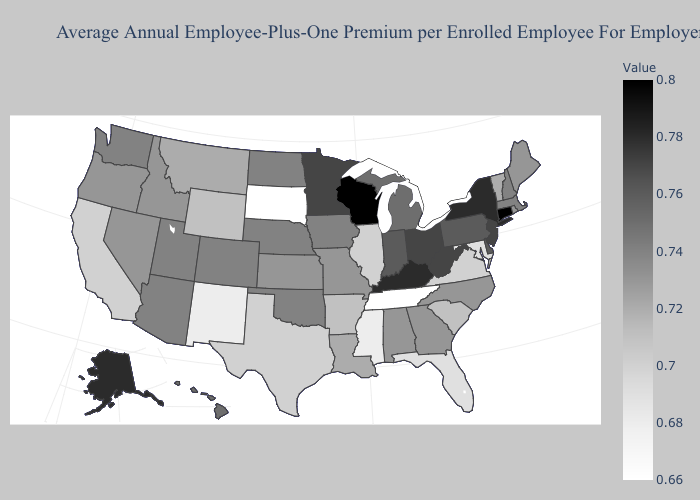Does the map have missing data?
Be succinct. No. Does Virginia have the highest value in the USA?
Write a very short answer. No. Which states have the lowest value in the USA?
Keep it brief. South Dakota, Tennessee. Which states hav the highest value in the Northeast?
Concise answer only. Connecticut. Which states have the lowest value in the USA?
Concise answer only. South Dakota, Tennessee. Which states have the lowest value in the South?
Give a very brief answer. Tennessee. 